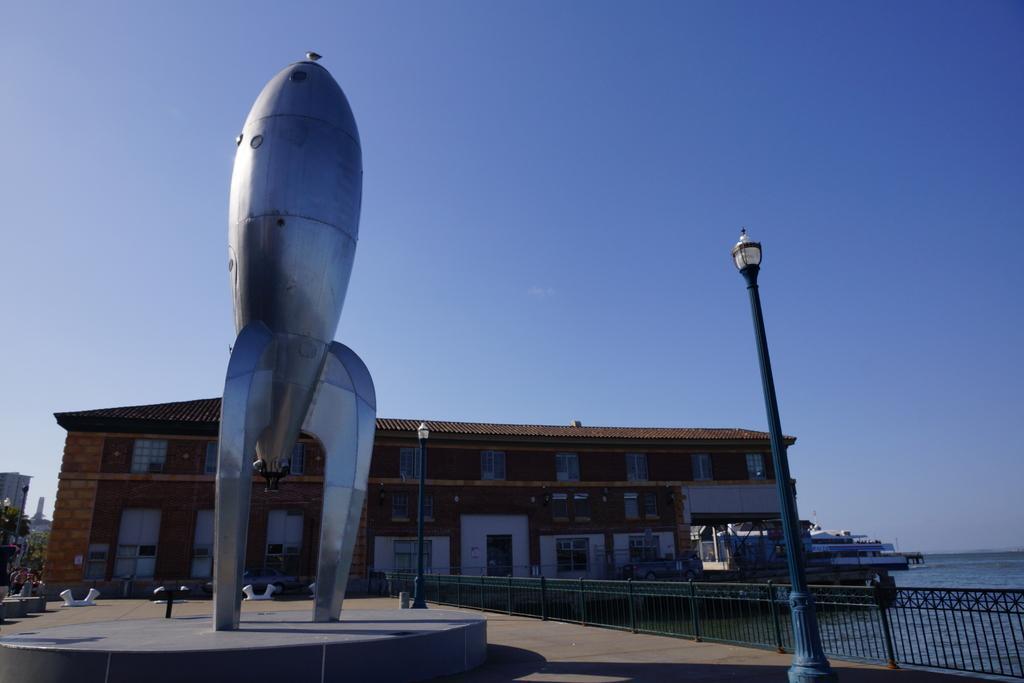Describe this image in one or two sentences. In the picture we can see an aircraft sculpture on the path and besides, we can see some lamps to the poles and near it, we can see a railing and behind it, we can see a water and in the background we can see a building and a sky. 